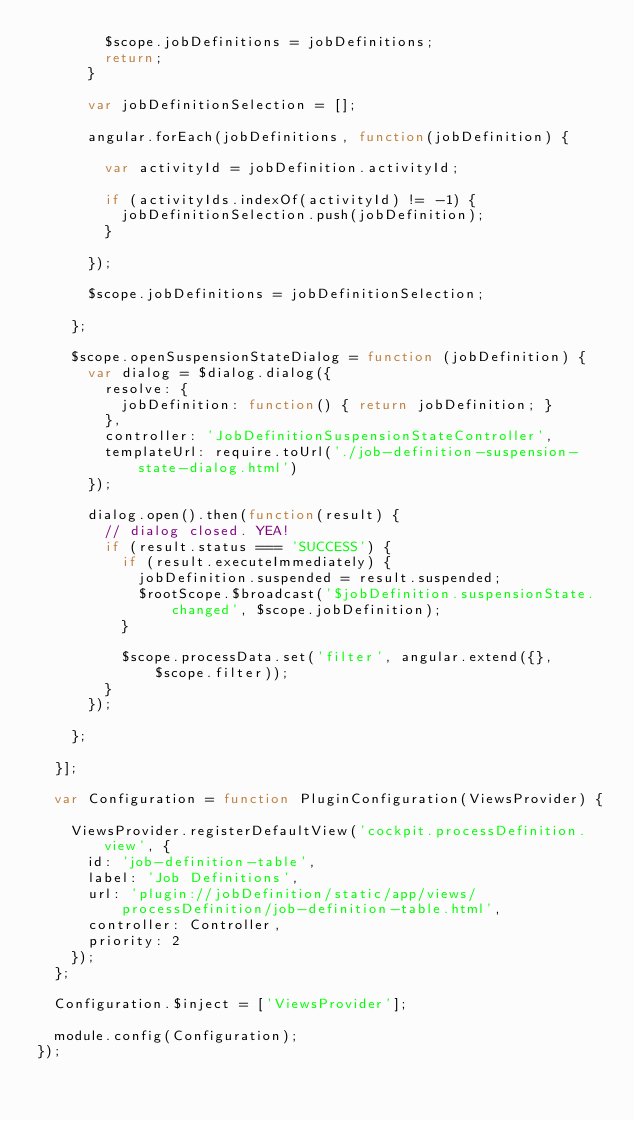<code> <loc_0><loc_0><loc_500><loc_500><_JavaScript_>        $scope.jobDefinitions = jobDefinitions;
        return;
      }

      var jobDefinitionSelection = [];

      angular.forEach(jobDefinitions, function(jobDefinition) {

        var activityId = jobDefinition.activityId;

        if (activityIds.indexOf(activityId) != -1) {
          jobDefinitionSelection.push(jobDefinition);
        }

      });

      $scope.jobDefinitions = jobDefinitionSelection;

    };

    $scope.openSuspensionStateDialog = function (jobDefinition) {
      var dialog = $dialog.dialog({
        resolve: {
          jobDefinition: function() { return jobDefinition; }
        },
        controller: 'JobDefinitionSuspensionStateController',
        templateUrl: require.toUrl('./job-definition-suspension-state-dialog.html')
      });

      dialog.open().then(function(result) {
        // dialog closed. YEA!
        if (result.status === 'SUCCESS') {
          if (result.executeImmediately) {
            jobDefinition.suspended = result.suspended;
            $rootScope.$broadcast('$jobDefinition.suspensionState.changed', $scope.jobDefinition);
          }

          $scope.processData.set('filter', angular.extend({}, $scope.filter));
        }
      });

    };

  }];

  var Configuration = function PluginConfiguration(ViewsProvider) {

    ViewsProvider.registerDefaultView('cockpit.processDefinition.view', {
      id: 'job-definition-table',
      label: 'Job Definitions',
      url: 'plugin://jobDefinition/static/app/views/processDefinition/job-definition-table.html',
      controller: Controller,
      priority: 2
    }); 
  };

  Configuration.$inject = ['ViewsProvider'];

  module.config(Configuration);
});
</code> 